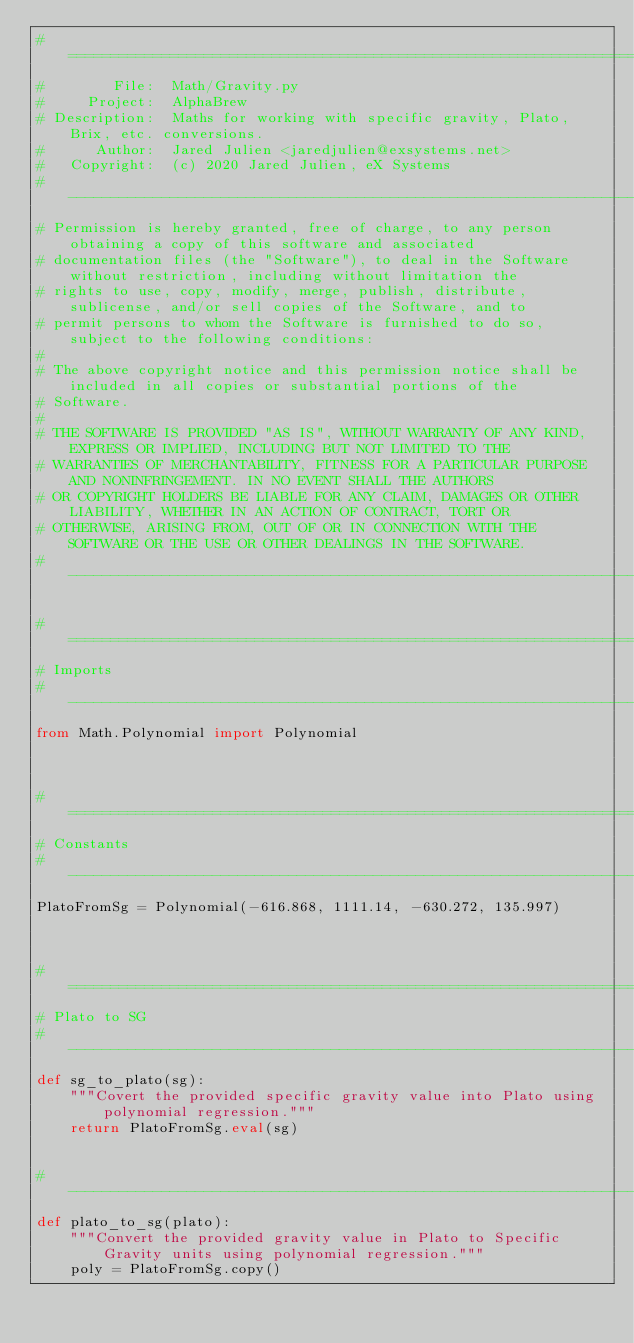Convert code to text. <code><loc_0><loc_0><loc_500><loc_500><_Python_># ======================================================================================================================
#        File:  Math/Gravity.py
#     Project:  AlphaBrew
# Description:  Maths for working with specific gravity, Plato, Brix, etc. conversions.
#      Author:  Jared Julien <jaredjulien@exsystems.net>
#   Copyright:  (c) 2020 Jared Julien, eX Systems
# ---------------------------------------------------------------------------------------------------------------------
# Permission is hereby granted, free of charge, to any person obtaining a copy of this software and associated
# documentation files (the "Software"), to deal in the Software without restriction, including without limitation the
# rights to use, copy, modify, merge, publish, distribute, sublicense, and/or sell copies of the Software, and to
# permit persons to whom the Software is furnished to do so, subject to the following conditions:
#
# The above copyright notice and this permission notice shall be included in all copies or substantial portions of the
# Software.
#
# THE SOFTWARE IS PROVIDED "AS IS", WITHOUT WARRANTY OF ANY KIND, EXPRESS OR IMPLIED, INCLUDING BUT NOT LIMITED TO THE
# WARRANTIES OF MERCHANTABILITY, FITNESS FOR A PARTICULAR PURPOSE AND NONINFRINGEMENT. IN NO EVENT SHALL THE AUTHORS
# OR COPYRIGHT HOLDERS BE LIABLE FOR ANY CLAIM, DAMAGES OR OTHER LIABILITY, WHETHER IN AN ACTION OF CONTRACT, TORT OR
# OTHERWISE, ARISING FROM, OUT OF OR IN CONNECTION WITH THE SOFTWARE OR THE USE OR OTHER DEALINGS IN THE SOFTWARE.
# ----------------------------------------------------------------------------------------------------------------------

# ======================================================================================================================
# Imports
# ----------------------------------------------------------------------------------------------------------------------
from Math.Polynomial import Polynomial



# ======================================================================================================================
# Constants
# ----------------------------------------------------------------------------------------------------------------------
PlatoFromSg = Polynomial(-616.868, 1111.14, -630.272, 135.997)



# ======================================================================================================================
# Plato to SG
# ----------------------------------------------------------------------------------------------------------------------
def sg_to_plato(sg):
    """Covert the provided specific gravity value into Plato using polynomial regression."""
    return PlatoFromSg.eval(sg)


# ----------------------------------------------------------------------------------------------------------------------
def plato_to_sg(plato):
    """Convert the provided gravity value in Plato to Specific Gravity units using polynomial regression."""
    poly = PlatoFromSg.copy()</code> 